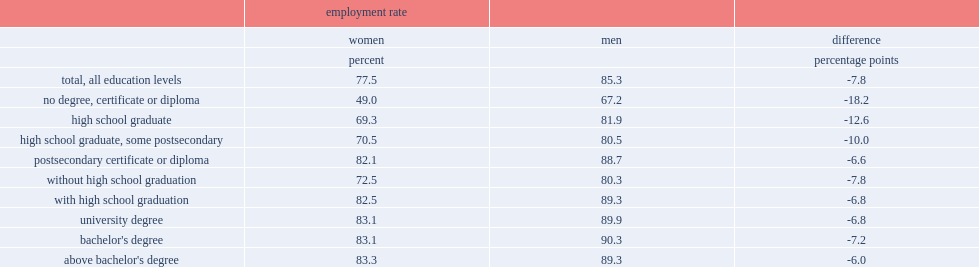In 2015, what was the employment rate of women with a high school diploma? 69.3. In 2015, what was the employment rate of women with a university degree? 83.1. In 2015, the employment rate of women with a high school diploma was 69.3% compared to 83.1% for those with a university degree, what was the difference of them? 13.8. What was the employment rate of men with a high school diploma? 81.9. What was the employment rate of men with a university degree? 89.9. The employment rate of men with a high school diploma was 81.9% compared to 89.9% for those with a university degree, what was the difference of them? 8. 